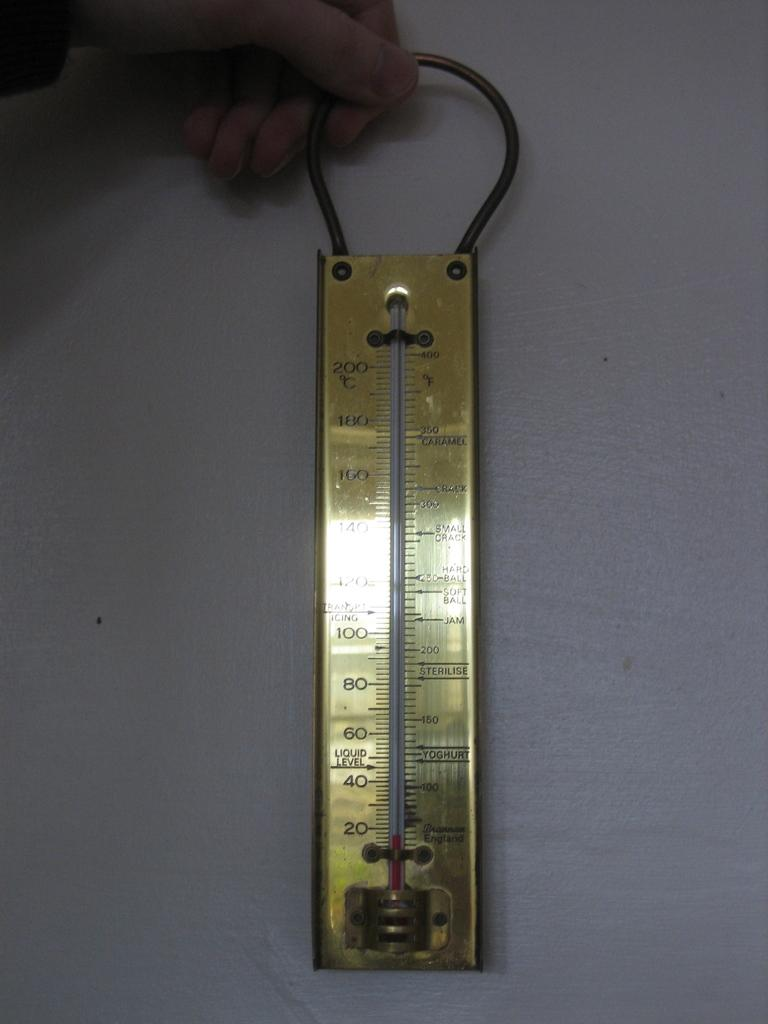<image>
Give a short and clear explanation of the subsequent image. A thermometer that goes up to a little over 400 degrees is held by a hand. 